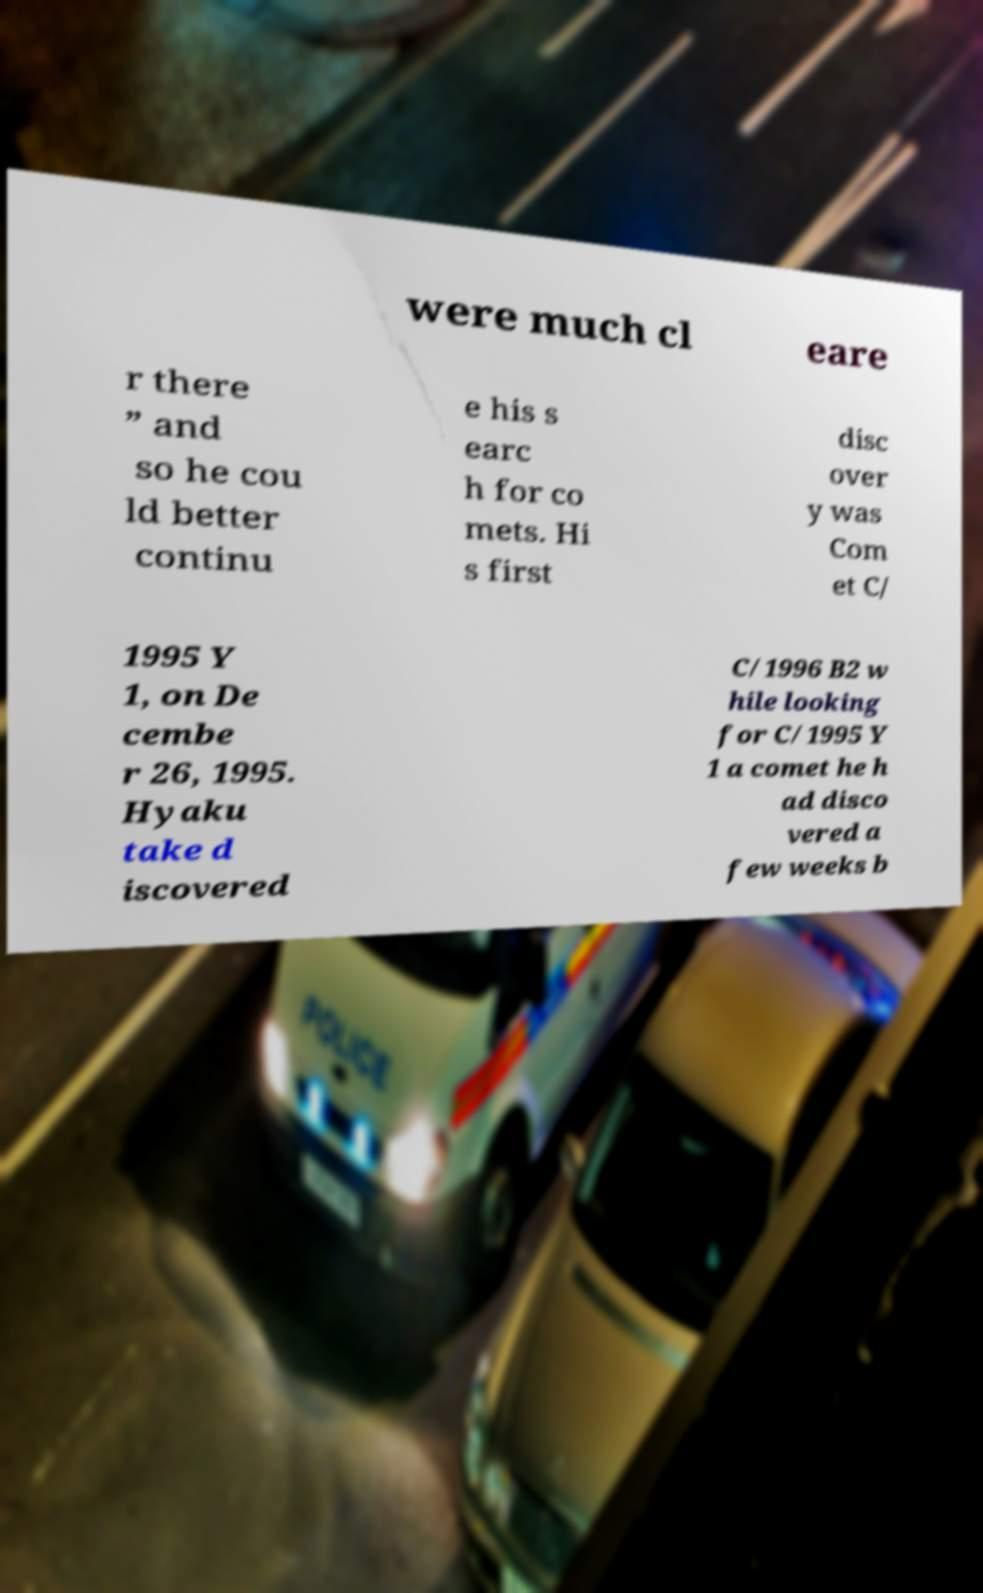Please read and relay the text visible in this image. What does it say? were much cl eare r there ” and so he cou ld better continu e his s earc h for co mets. Hi s first disc over y was Com et C/ 1995 Y 1, on De cembe r 26, 1995. Hyaku take d iscovered C/1996 B2 w hile looking for C/1995 Y 1 a comet he h ad disco vered a few weeks b 